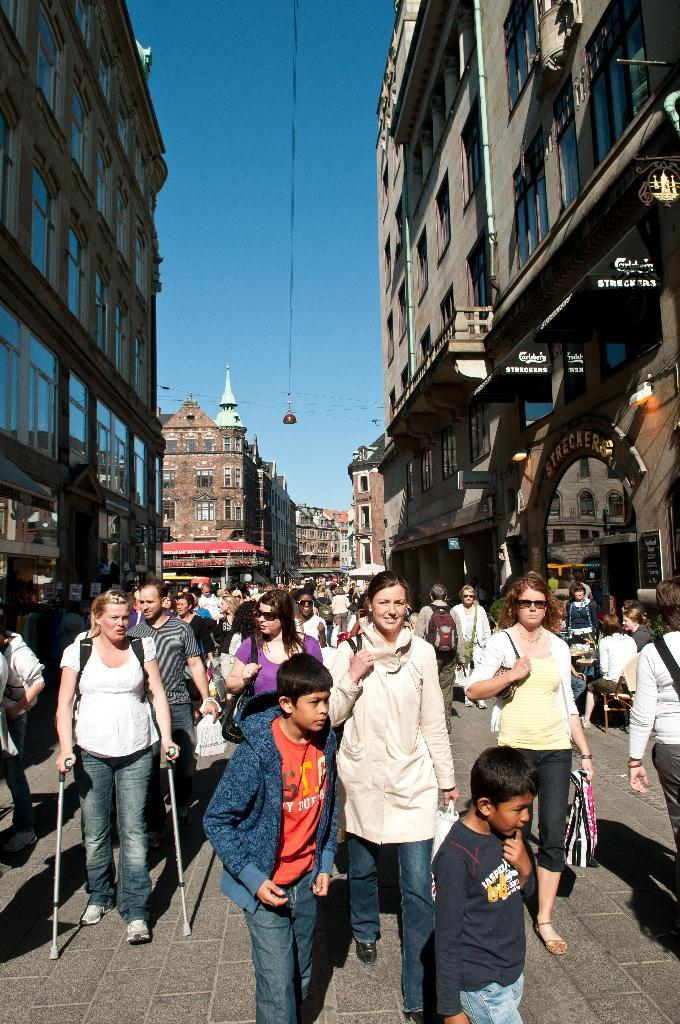What is happening on the road in the image? There are many people on the road in the image. What can be seen on the left side of the image? There are buildings on the left side of the image. What can be seen on the right side of the image? There are buildings on the right side of the image. What type of illumination is present in the image? The image includes lights. What is visible at the top of the image? The sky is visible at the top of the image. What month is it in the image? The month cannot be determined from the image, as it does not include any information about the time of year. What type of property is being sold in the image? There is no property being sold in the image; it features people on the road and buildings on both sides. 